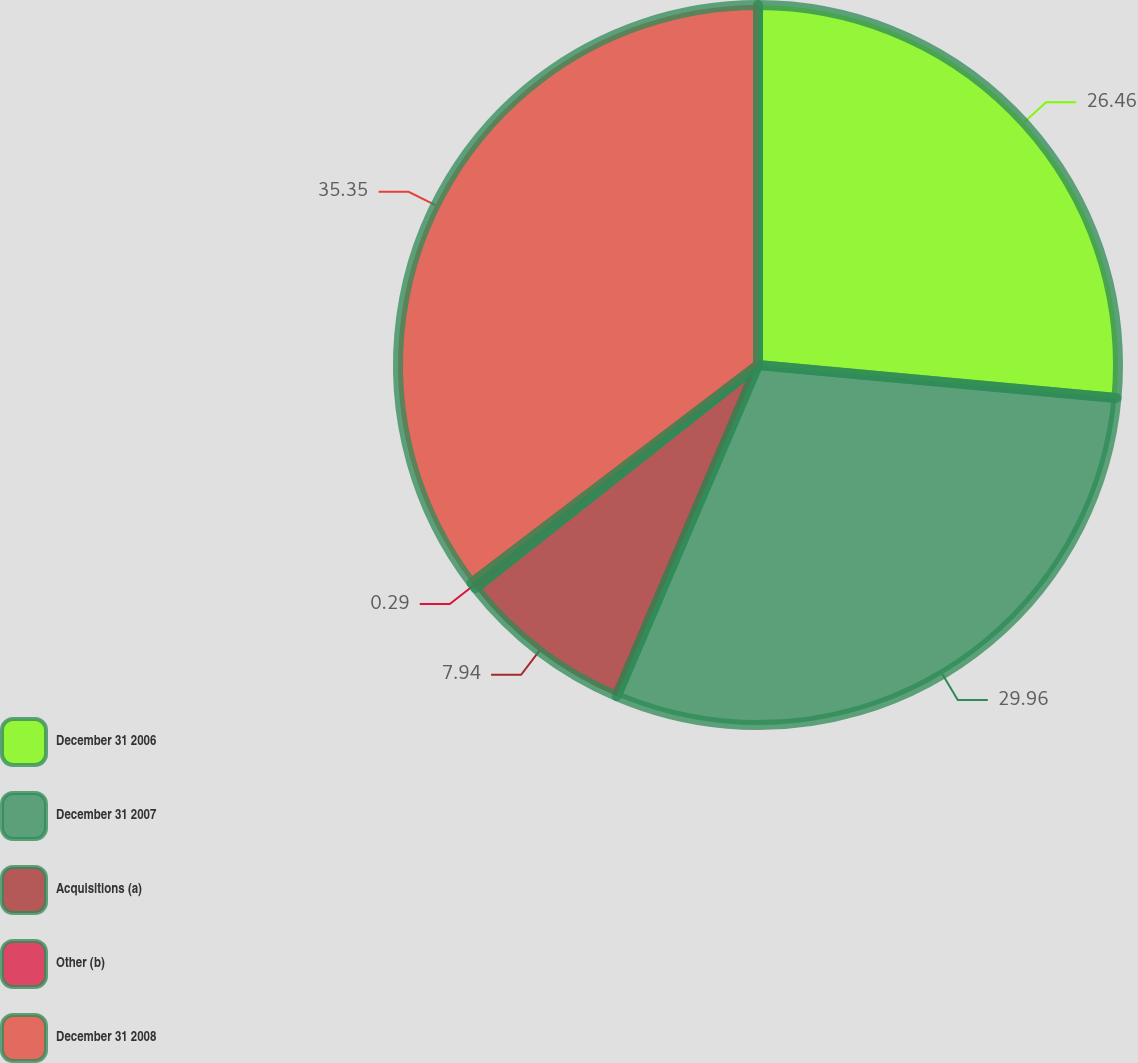<chart> <loc_0><loc_0><loc_500><loc_500><pie_chart><fcel>December 31 2006<fcel>December 31 2007<fcel>Acquisitions (a)<fcel>Other (b)<fcel>December 31 2008<nl><fcel>26.46%<fcel>29.96%<fcel>7.94%<fcel>0.29%<fcel>35.35%<nl></chart> 